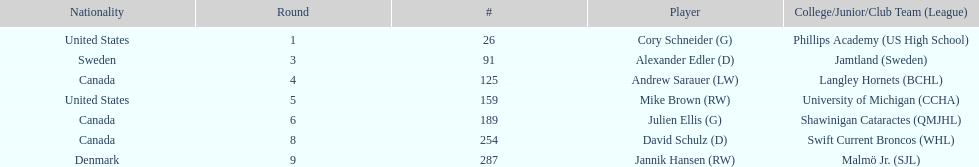Who is the only player to have denmark listed as their nationality? Jannik Hansen (RW). Give me the full table as a dictionary. {'header': ['Nationality', 'Round', '#', 'Player', 'College/Junior/Club Team (League)'], 'rows': [['United States', '1', '26', 'Cory Schneider (G)', 'Phillips Academy (US High School)'], ['Sweden', '3', '91', 'Alexander Edler (D)', 'Jamtland (Sweden)'], ['Canada', '4', '125', 'Andrew Sarauer (LW)', 'Langley Hornets (BCHL)'], ['United States', '5', '159', 'Mike Brown (RW)', 'University of Michigan (CCHA)'], ['Canada', '6', '189', 'Julien Ellis (G)', 'Shawinigan Cataractes (QMJHL)'], ['Canada', '8', '254', 'David Schulz (D)', 'Swift Current Broncos (WHL)'], ['Denmark', '9', '287', 'Jannik Hansen (RW)', 'Malmö Jr. (SJL)']]} 